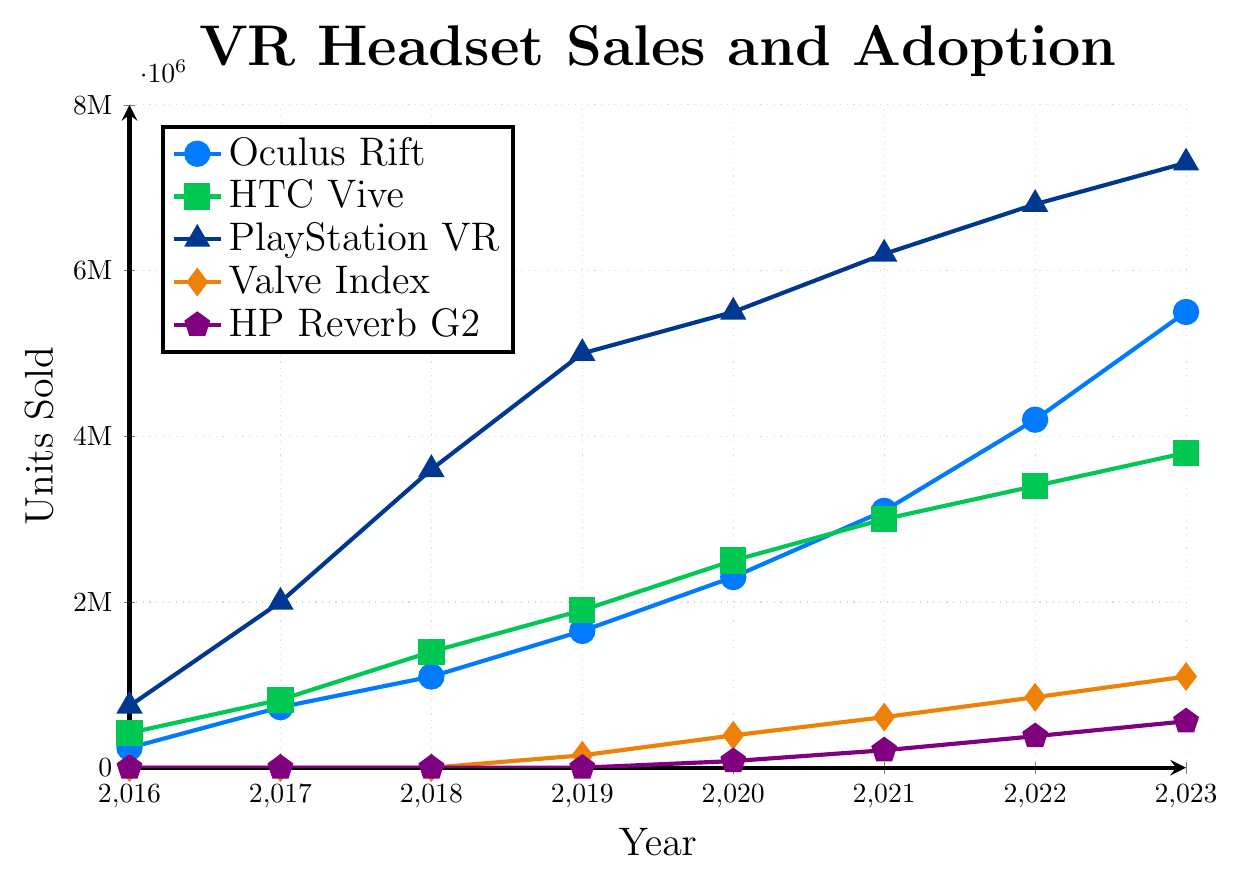What year did PlayStation VR surpass 5 million units sold? To answer this, identify the data point where PlayStation VR's sales first exceed 5 million. In 2019, PlayStation VR sold 5 million units.
Answer: 2019 Which VR headset had the steepest growth in sales between 2016 and 2023? Identify which line on the chart has the steepest slope. The steep slope represents a rapid increase in sales over time. PlayStation VR grew from 745,000 in 2016 to 7.3 million in 2023.
Answer: PlayStation VR What is the difference in units sold between HTC Vive and Valve Index in 2020? Subtract the units sold by Valve Index from the units sold by HTC Vive in 2020. HTC Vive sold 2.5 million units and Valve Index sold 390,000 units in 2020. 2,500,000 - 390,000 = 2,110,000.
Answer: 2,110,000 Which VR headset was introduced latest into the consumer market based on the data? Observe the sale values; the headset with the zero values for the first few years is the latest introduction. HP Reverb G2 has sales data starting from 2020, indicating it was introduced the latest.
Answer: HP Reverb G2 In terms of visual appearance, which VR headset’s sales increase is represented by a line colored green? Identify the color green used in the chart, which represents HTC Vive.
Answer: HTC Vive What is the combined sales of Oculus Rift and Valve Index in 2023? Sum the sales of Oculus Rift and Valve Index for the year 2023. Oculus Rift: 5,500,000 units + Valve Index: 1,100,000 units. 5,500,000 + 1,100,000 = 6,600,000.
Answer: 6,600,000 Which VR headset had zero sales in 2016 and 2017, but reached over half a million units by 2023? Identify the headsets with zero sales in 2016 and 2017, then check which of them had over 500,000 units sold in 2023. HP Reverb G2 fits this scenario, selling 560,000 units in 2023.
Answer: HP Reverb G2 Compared to 2017, by how much did the sales of HTC Vive increase in 2019? Subtract the sales number in 2017 from the sales number in 2019 for HTC Vive. Sales in 2017 were 820,000 units, in 2019 they were 1,900,000. 1,900,000 - 820,000 = 1,080,000.
Answer: 1,080,000 In 2021, which VR headset sold the most units? Identify the headset with the highest sales value in the year 2021. PlayStation VR sold 6.2 million units, which is the maximum in 2021.
Answer: PlayStation VR How much did the sales of Oculus Rift increase on average per year between 2016 and 2023? Calculate the total increase over the years, then divide by the number of years. Increased sales = 5,500,000 - 240,000 = 5,260,000 units. Number of years = 2023 - 2016 = 7 years. 5,260,000 / 7 = 751,428.57 units.
Answer: 751,428.57 units 